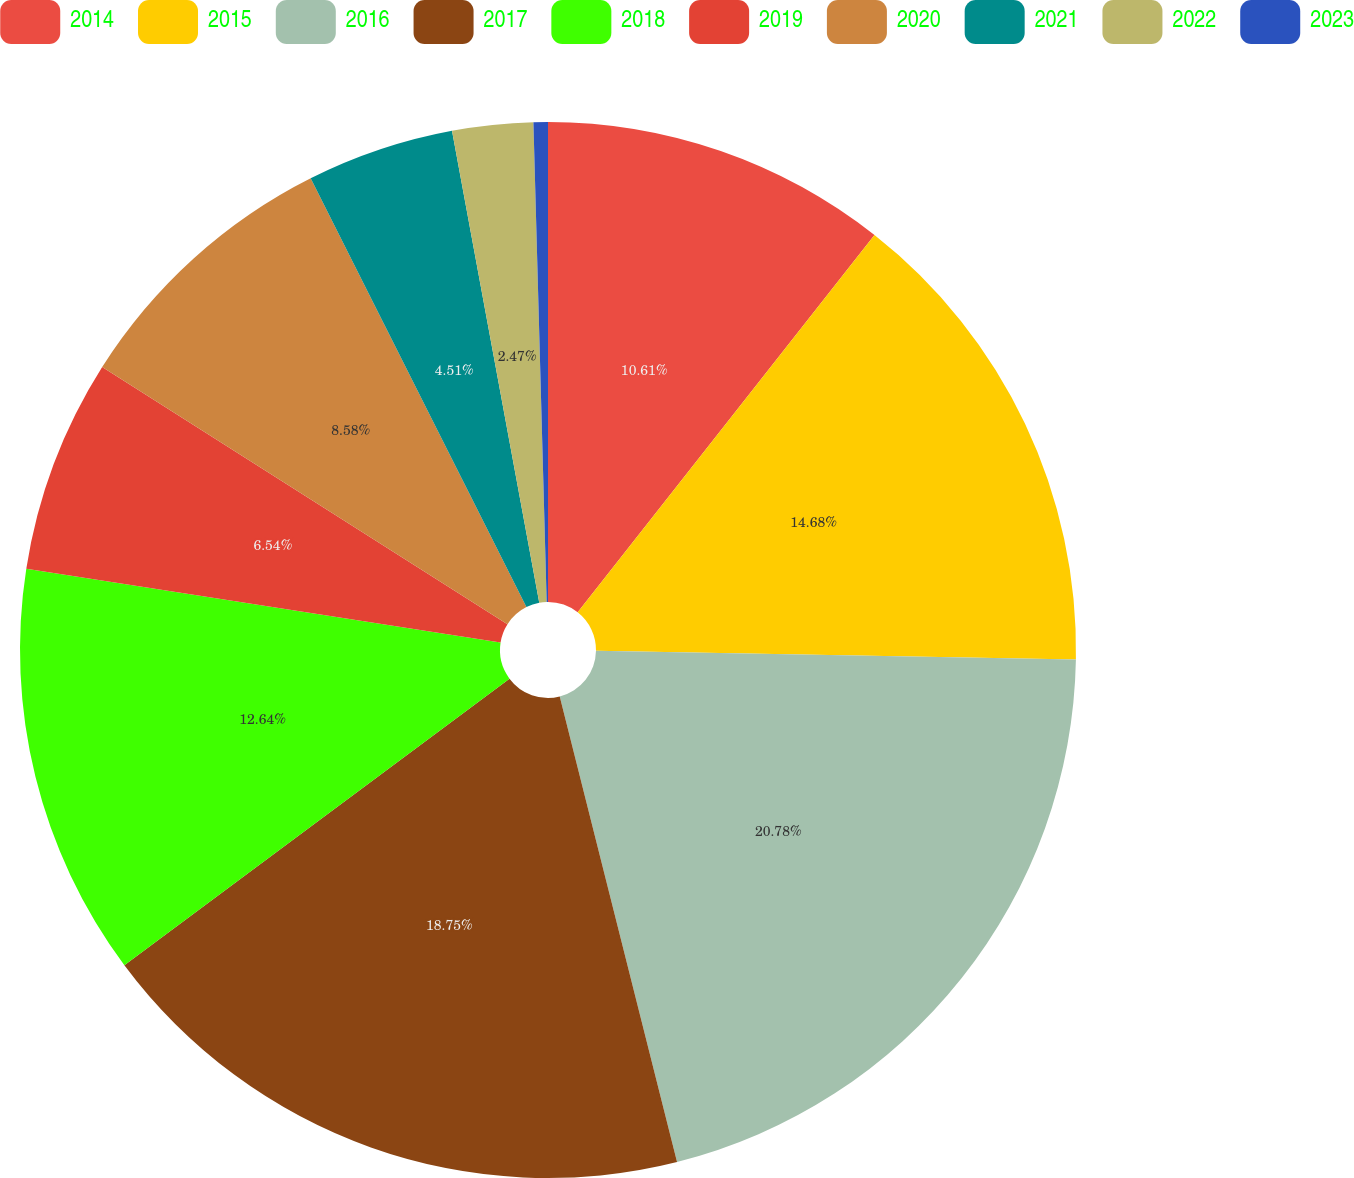Convert chart. <chart><loc_0><loc_0><loc_500><loc_500><pie_chart><fcel>2014<fcel>2015<fcel>2016<fcel>2017<fcel>2018<fcel>2019<fcel>2020<fcel>2021<fcel>2022<fcel>2023<nl><fcel>10.61%<fcel>14.68%<fcel>20.78%<fcel>18.75%<fcel>12.64%<fcel>6.54%<fcel>8.58%<fcel>4.51%<fcel>2.47%<fcel>0.44%<nl></chart> 